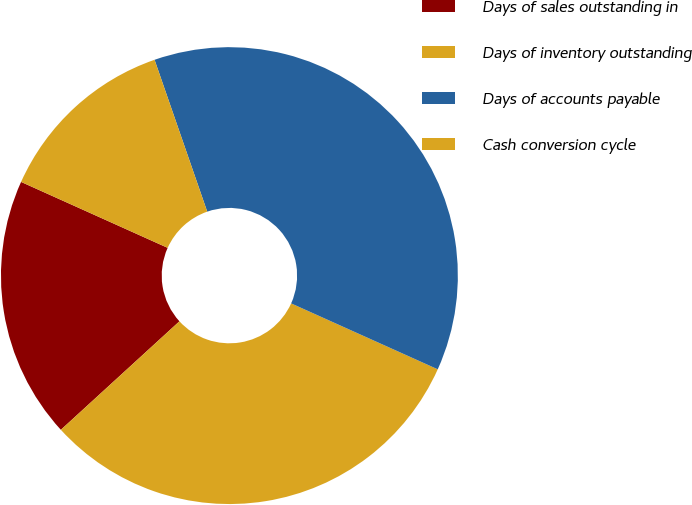Convert chart to OTSL. <chart><loc_0><loc_0><loc_500><loc_500><pie_chart><fcel>Days of sales outstanding in<fcel>Days of inventory outstanding<fcel>Days of accounts payable<fcel>Cash conversion cycle<nl><fcel>18.52%<fcel>31.48%<fcel>37.04%<fcel>12.96%<nl></chart> 